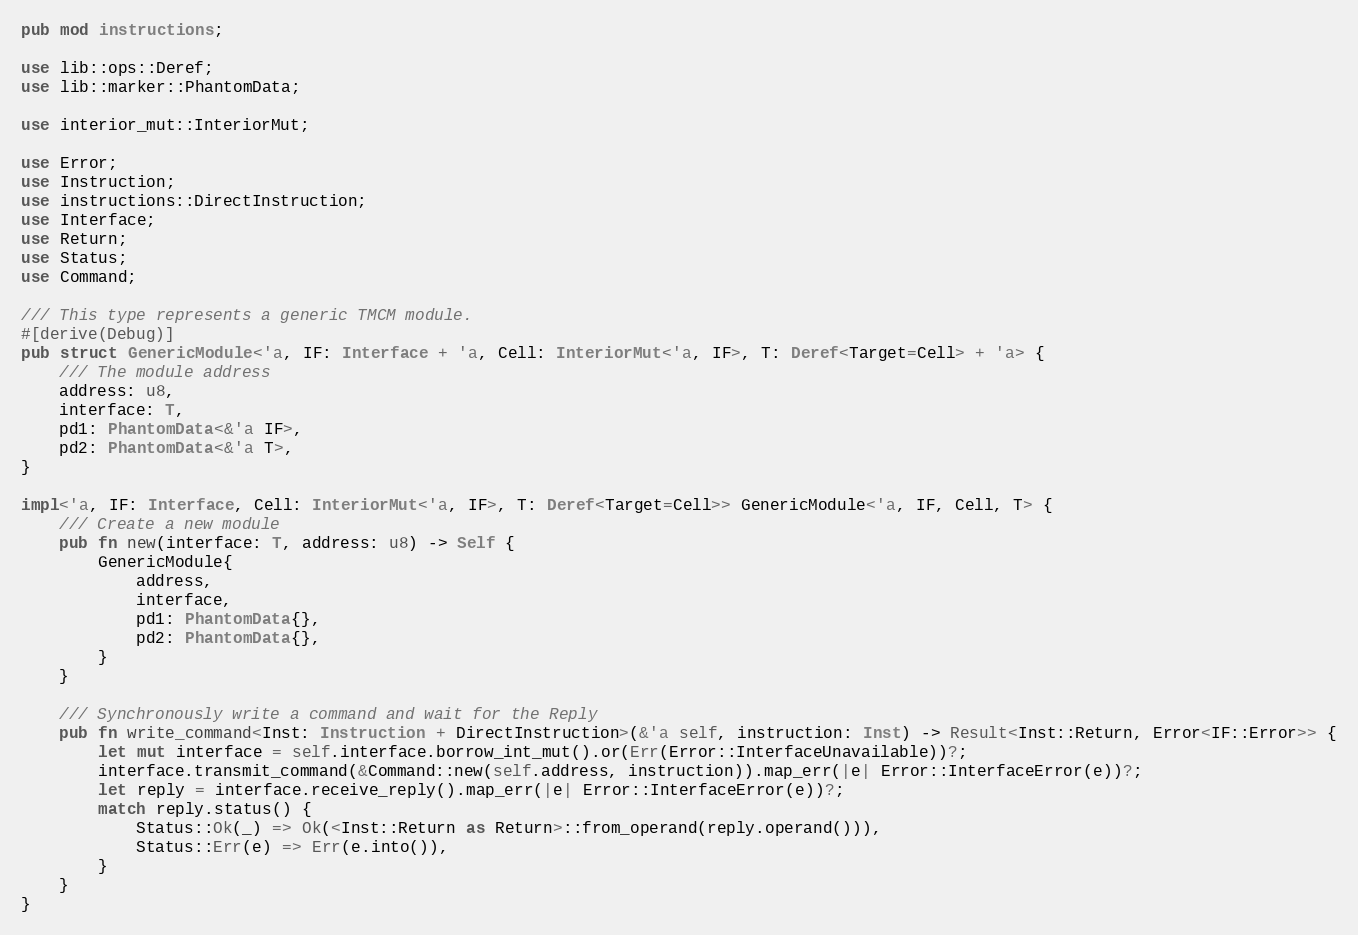<code> <loc_0><loc_0><loc_500><loc_500><_Rust_>
pub mod instructions;

use lib::ops::Deref;
use lib::marker::PhantomData;

use interior_mut::InteriorMut;

use Error;
use Instruction;
use instructions::DirectInstruction;
use Interface;
use Return;
use Status;
use Command;

/// This type represents a generic TMCM module.
#[derive(Debug)]
pub struct GenericModule<'a, IF: Interface + 'a, Cell: InteriorMut<'a, IF>, T: Deref<Target=Cell> + 'a> {
    /// The module address
    address: u8,
    interface: T,
    pd1: PhantomData<&'a IF>,
    pd2: PhantomData<&'a T>,
}

impl<'a, IF: Interface, Cell: InteriorMut<'a, IF>, T: Deref<Target=Cell>> GenericModule<'a, IF, Cell, T> {
    /// Create a new module
    pub fn new(interface: T, address: u8) -> Self {
        GenericModule{
            address,
            interface,
            pd1: PhantomData{},
            pd2: PhantomData{},
        }
    }

    /// Synchronously write a command and wait for the Reply
    pub fn write_command<Inst: Instruction + DirectInstruction>(&'a self, instruction: Inst) -> Result<Inst::Return, Error<IF::Error>> {
        let mut interface = self.interface.borrow_int_mut().or(Err(Error::InterfaceUnavailable))?;
        interface.transmit_command(&Command::new(self.address, instruction)).map_err(|e| Error::InterfaceError(e))?;
        let reply = interface.receive_reply().map_err(|e| Error::InterfaceError(e))?;
        match reply.status() {
            Status::Ok(_) => Ok(<Inst::Return as Return>::from_operand(reply.operand())),
            Status::Err(e) => Err(e.into()),
        }
    }
}</code> 